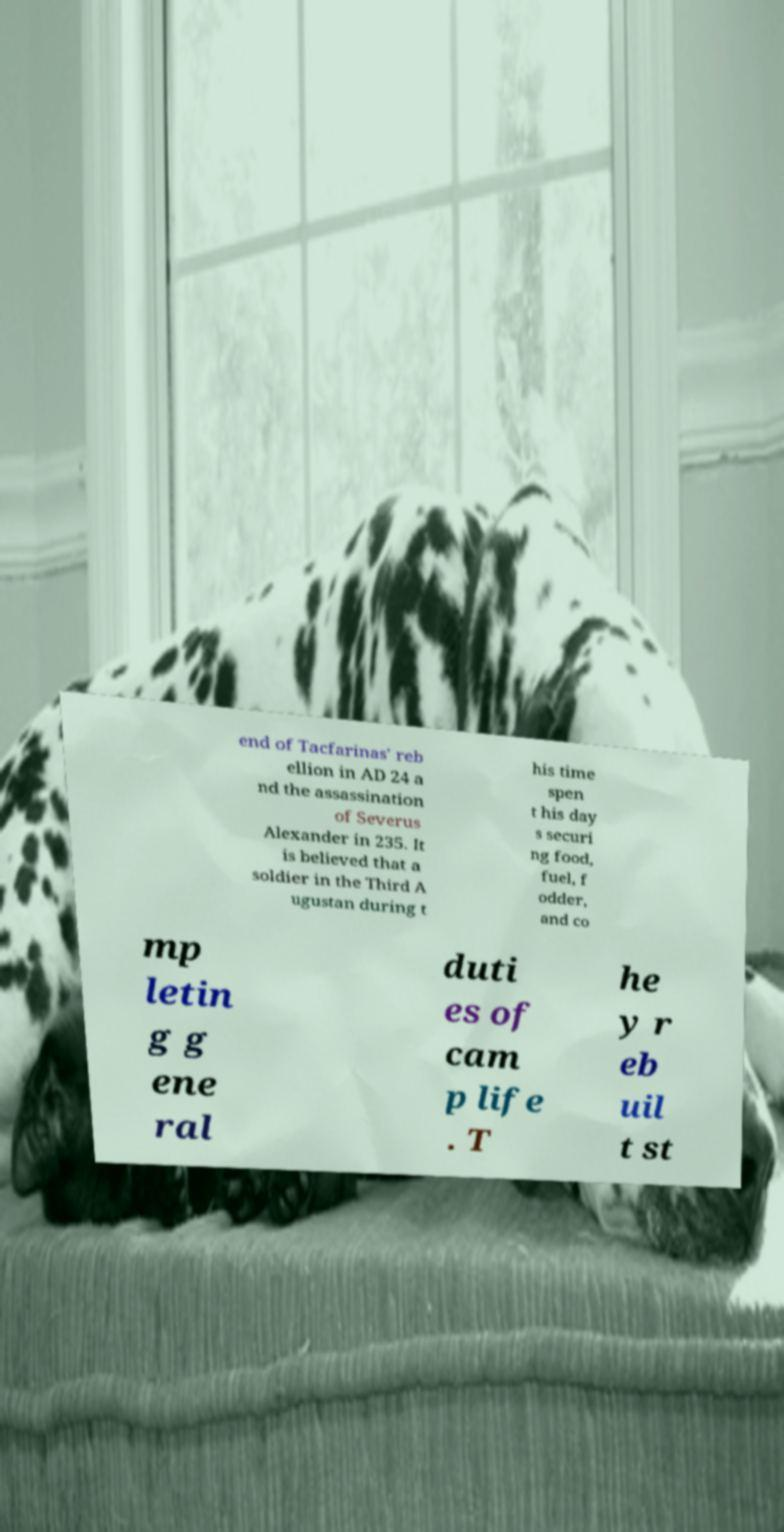Could you extract and type out the text from this image? end of Tacfarinas' reb ellion in AD 24 a nd the assassination of Severus Alexander in 235. It is believed that a soldier in the Third A ugustan during t his time spen t his day s securi ng food, fuel, f odder, and co mp letin g g ene ral duti es of cam p life . T he y r eb uil t st 